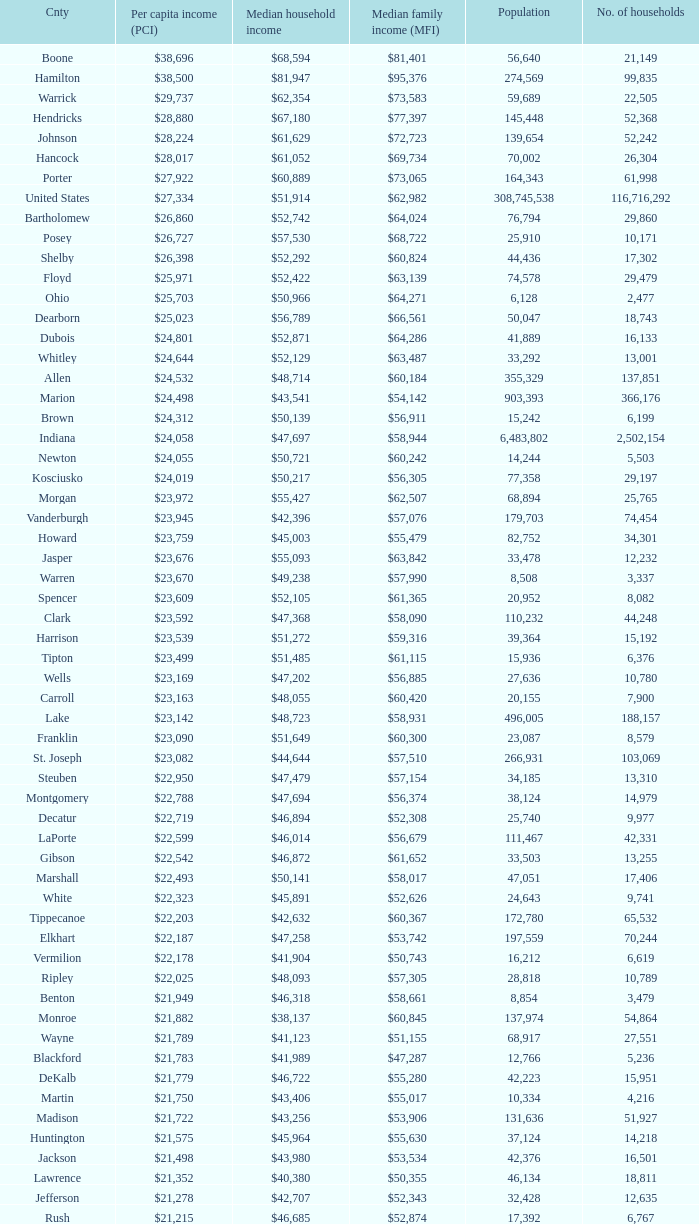What County has a Median household income of $46,872? Gibson. 